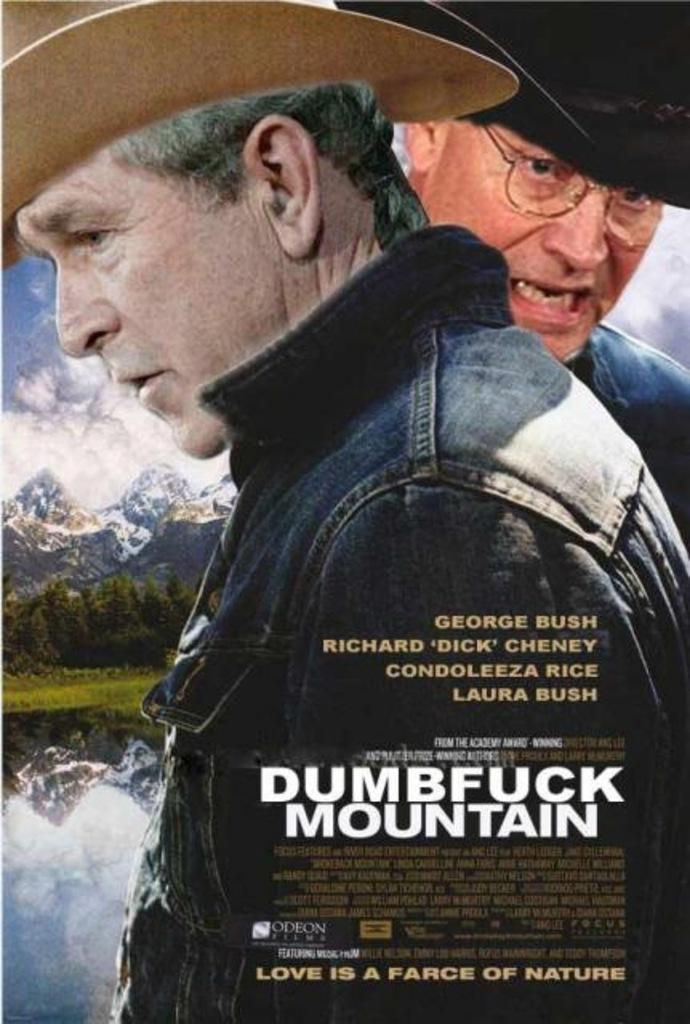Could you give a brief overview of what you see in this image? As we can see in the image there is a banner. On banner there are two people wearing black color jackets, water, hills, sky and some matter written. 